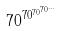<formula> <loc_0><loc_0><loc_500><loc_500>7 0 ^ { 7 0 ^ { 7 0 ^ { 7 0 ^ { \dots } } } }</formula> 